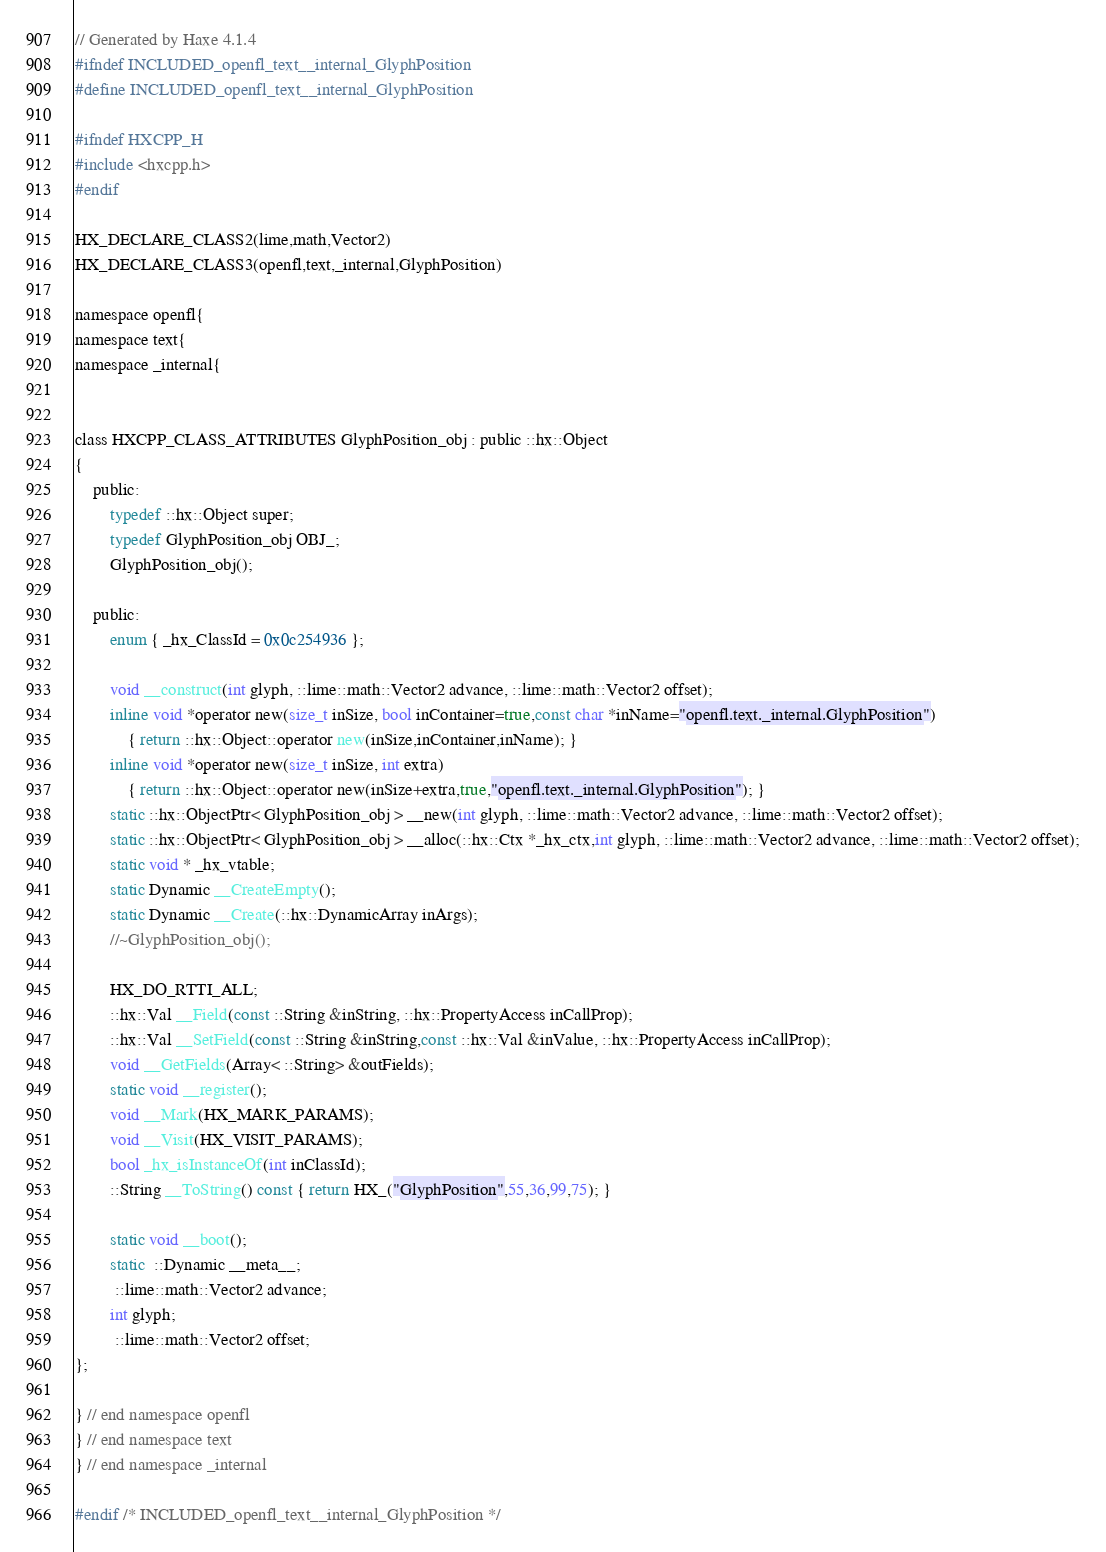<code> <loc_0><loc_0><loc_500><loc_500><_C_>// Generated by Haxe 4.1.4
#ifndef INCLUDED_openfl_text__internal_GlyphPosition
#define INCLUDED_openfl_text__internal_GlyphPosition

#ifndef HXCPP_H
#include <hxcpp.h>
#endif

HX_DECLARE_CLASS2(lime,math,Vector2)
HX_DECLARE_CLASS3(openfl,text,_internal,GlyphPosition)

namespace openfl{
namespace text{
namespace _internal{


class HXCPP_CLASS_ATTRIBUTES GlyphPosition_obj : public ::hx::Object
{
	public:
		typedef ::hx::Object super;
		typedef GlyphPosition_obj OBJ_;
		GlyphPosition_obj();

	public:
		enum { _hx_ClassId = 0x0c254936 };

		void __construct(int glyph, ::lime::math::Vector2 advance, ::lime::math::Vector2 offset);
		inline void *operator new(size_t inSize, bool inContainer=true,const char *inName="openfl.text._internal.GlyphPosition")
			{ return ::hx::Object::operator new(inSize,inContainer,inName); }
		inline void *operator new(size_t inSize, int extra)
			{ return ::hx::Object::operator new(inSize+extra,true,"openfl.text._internal.GlyphPosition"); }
		static ::hx::ObjectPtr< GlyphPosition_obj > __new(int glyph, ::lime::math::Vector2 advance, ::lime::math::Vector2 offset);
		static ::hx::ObjectPtr< GlyphPosition_obj > __alloc(::hx::Ctx *_hx_ctx,int glyph, ::lime::math::Vector2 advance, ::lime::math::Vector2 offset);
		static void * _hx_vtable;
		static Dynamic __CreateEmpty();
		static Dynamic __Create(::hx::DynamicArray inArgs);
		//~GlyphPosition_obj();

		HX_DO_RTTI_ALL;
		::hx::Val __Field(const ::String &inString, ::hx::PropertyAccess inCallProp);
		::hx::Val __SetField(const ::String &inString,const ::hx::Val &inValue, ::hx::PropertyAccess inCallProp);
		void __GetFields(Array< ::String> &outFields);
		static void __register();
		void __Mark(HX_MARK_PARAMS);
		void __Visit(HX_VISIT_PARAMS);
		bool _hx_isInstanceOf(int inClassId);
		::String __ToString() const { return HX_("GlyphPosition",55,36,99,75); }

		static void __boot();
		static  ::Dynamic __meta__;
		 ::lime::math::Vector2 advance;
		int glyph;
		 ::lime::math::Vector2 offset;
};

} // end namespace openfl
} // end namespace text
} // end namespace _internal

#endif /* INCLUDED_openfl_text__internal_GlyphPosition */ 
</code> 